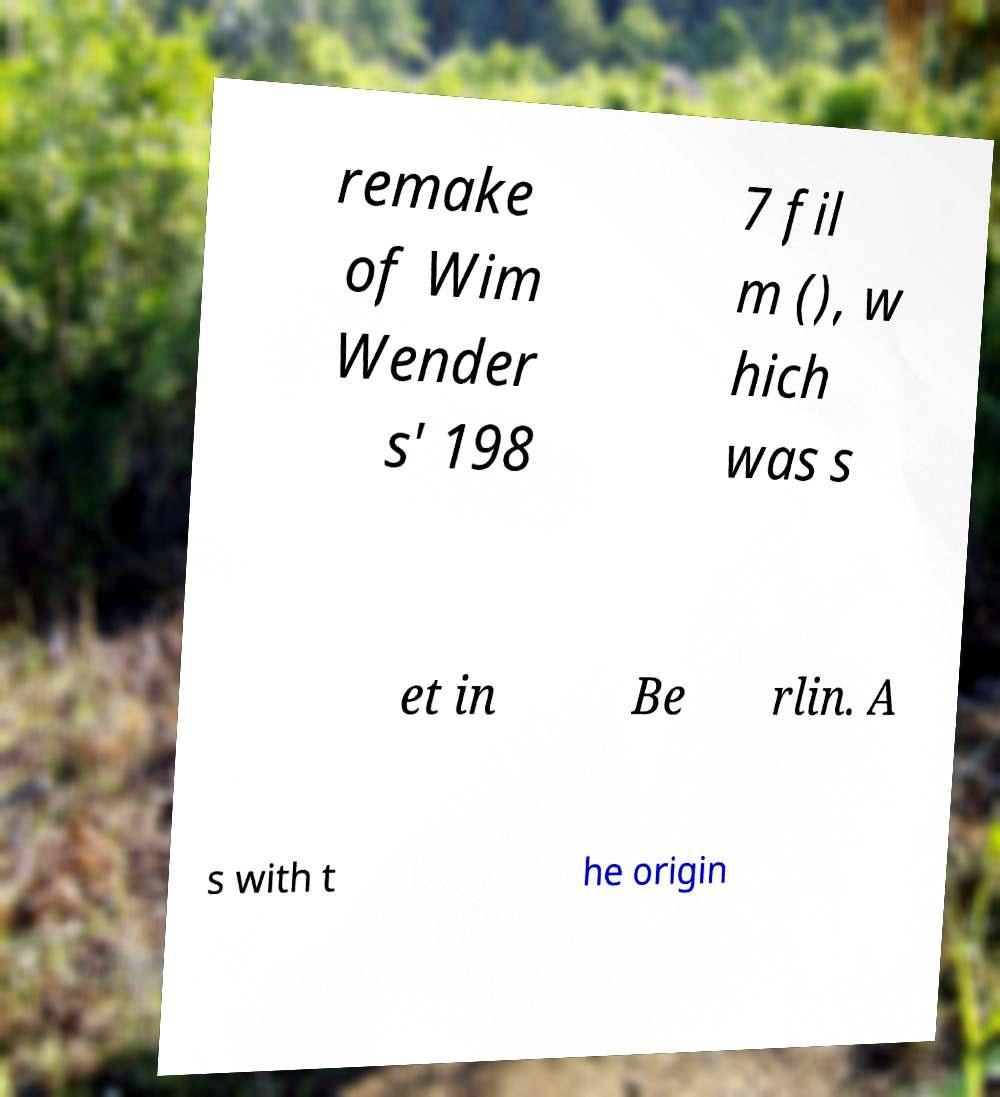Can you read and provide the text displayed in the image?This photo seems to have some interesting text. Can you extract and type it out for me? remake of Wim Wender s' 198 7 fil m (), w hich was s et in Be rlin. A s with t he origin 